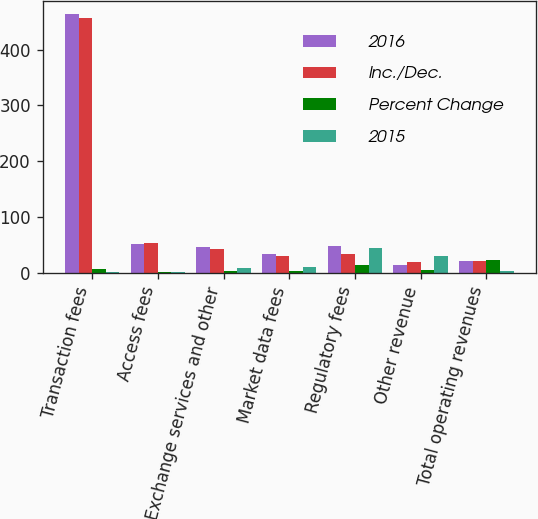Convert chart. <chart><loc_0><loc_0><loc_500><loc_500><stacked_bar_chart><ecel><fcel>Transaction fees<fcel>Access fees<fcel>Exchange services and other<fcel>Market data fees<fcel>Regulatory fees<fcel>Other revenue<fcel>Total operating revenues<nl><fcel>2016<fcel>463.3<fcel>52.3<fcel>46.3<fcel>33.2<fcel>48.3<fcel>13.5<fcel>20.95<nl><fcel>Inc./Dec.<fcel>456<fcel>53.3<fcel>42.2<fcel>30<fcel>33.5<fcel>19.5<fcel>20.95<nl><fcel>Percent Change<fcel>7.3<fcel>1<fcel>4.1<fcel>3.2<fcel>14.8<fcel>6<fcel>22.4<nl><fcel>2015<fcel>1.6<fcel>1.8<fcel>9.6<fcel>10.4<fcel>44.3<fcel>30.5<fcel>3.5<nl></chart> 